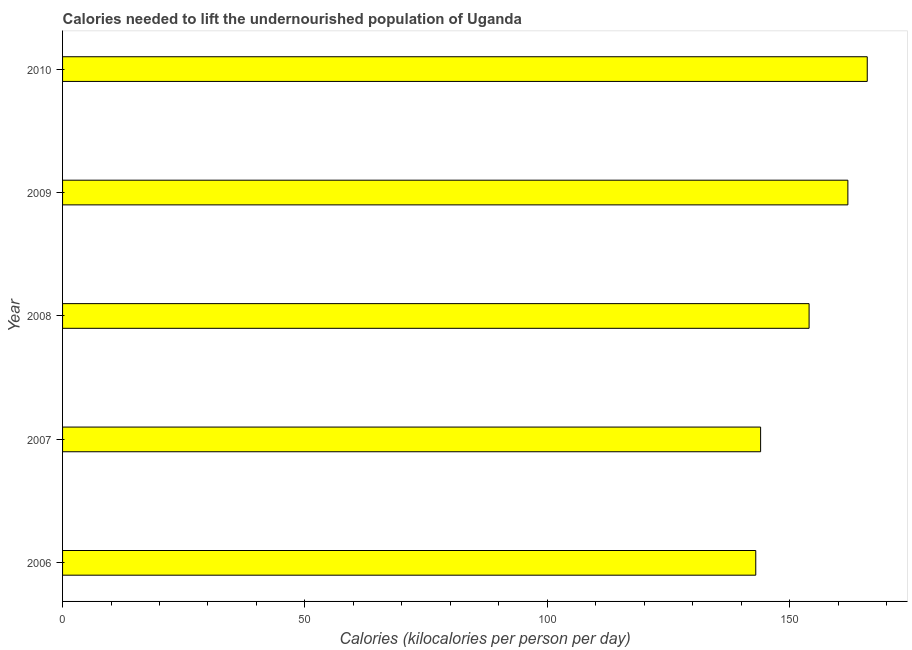Does the graph contain any zero values?
Give a very brief answer. No. What is the title of the graph?
Provide a short and direct response. Calories needed to lift the undernourished population of Uganda. What is the label or title of the X-axis?
Provide a short and direct response. Calories (kilocalories per person per day). What is the label or title of the Y-axis?
Provide a short and direct response. Year. What is the depth of food deficit in 2007?
Provide a short and direct response. 144. Across all years, what is the maximum depth of food deficit?
Offer a terse response. 166. Across all years, what is the minimum depth of food deficit?
Keep it short and to the point. 143. In which year was the depth of food deficit maximum?
Provide a succinct answer. 2010. In which year was the depth of food deficit minimum?
Keep it short and to the point. 2006. What is the sum of the depth of food deficit?
Provide a short and direct response. 769. What is the average depth of food deficit per year?
Offer a very short reply. 153. What is the median depth of food deficit?
Your response must be concise. 154. What is the ratio of the depth of food deficit in 2008 to that in 2010?
Give a very brief answer. 0.93. Is the depth of food deficit in 2007 less than that in 2010?
Provide a succinct answer. Yes. What is the difference between the highest and the second highest depth of food deficit?
Ensure brevity in your answer.  4. What is the difference between two consecutive major ticks on the X-axis?
Offer a very short reply. 50. What is the Calories (kilocalories per person per day) in 2006?
Offer a very short reply. 143. What is the Calories (kilocalories per person per day) in 2007?
Give a very brief answer. 144. What is the Calories (kilocalories per person per day) in 2008?
Your answer should be very brief. 154. What is the Calories (kilocalories per person per day) in 2009?
Offer a terse response. 162. What is the Calories (kilocalories per person per day) in 2010?
Your answer should be very brief. 166. What is the difference between the Calories (kilocalories per person per day) in 2006 and 2007?
Make the answer very short. -1. What is the difference between the Calories (kilocalories per person per day) in 2006 and 2008?
Offer a terse response. -11. What is the difference between the Calories (kilocalories per person per day) in 2006 and 2009?
Give a very brief answer. -19. What is the difference between the Calories (kilocalories per person per day) in 2007 and 2008?
Give a very brief answer. -10. What is the difference between the Calories (kilocalories per person per day) in 2007 and 2009?
Your answer should be very brief. -18. What is the difference between the Calories (kilocalories per person per day) in 2009 and 2010?
Your answer should be compact. -4. What is the ratio of the Calories (kilocalories per person per day) in 2006 to that in 2008?
Your response must be concise. 0.93. What is the ratio of the Calories (kilocalories per person per day) in 2006 to that in 2009?
Make the answer very short. 0.88. What is the ratio of the Calories (kilocalories per person per day) in 2006 to that in 2010?
Offer a very short reply. 0.86. What is the ratio of the Calories (kilocalories per person per day) in 2007 to that in 2008?
Your response must be concise. 0.94. What is the ratio of the Calories (kilocalories per person per day) in 2007 to that in 2009?
Offer a very short reply. 0.89. What is the ratio of the Calories (kilocalories per person per day) in 2007 to that in 2010?
Give a very brief answer. 0.87. What is the ratio of the Calories (kilocalories per person per day) in 2008 to that in 2009?
Offer a very short reply. 0.95. What is the ratio of the Calories (kilocalories per person per day) in 2008 to that in 2010?
Keep it short and to the point. 0.93. 